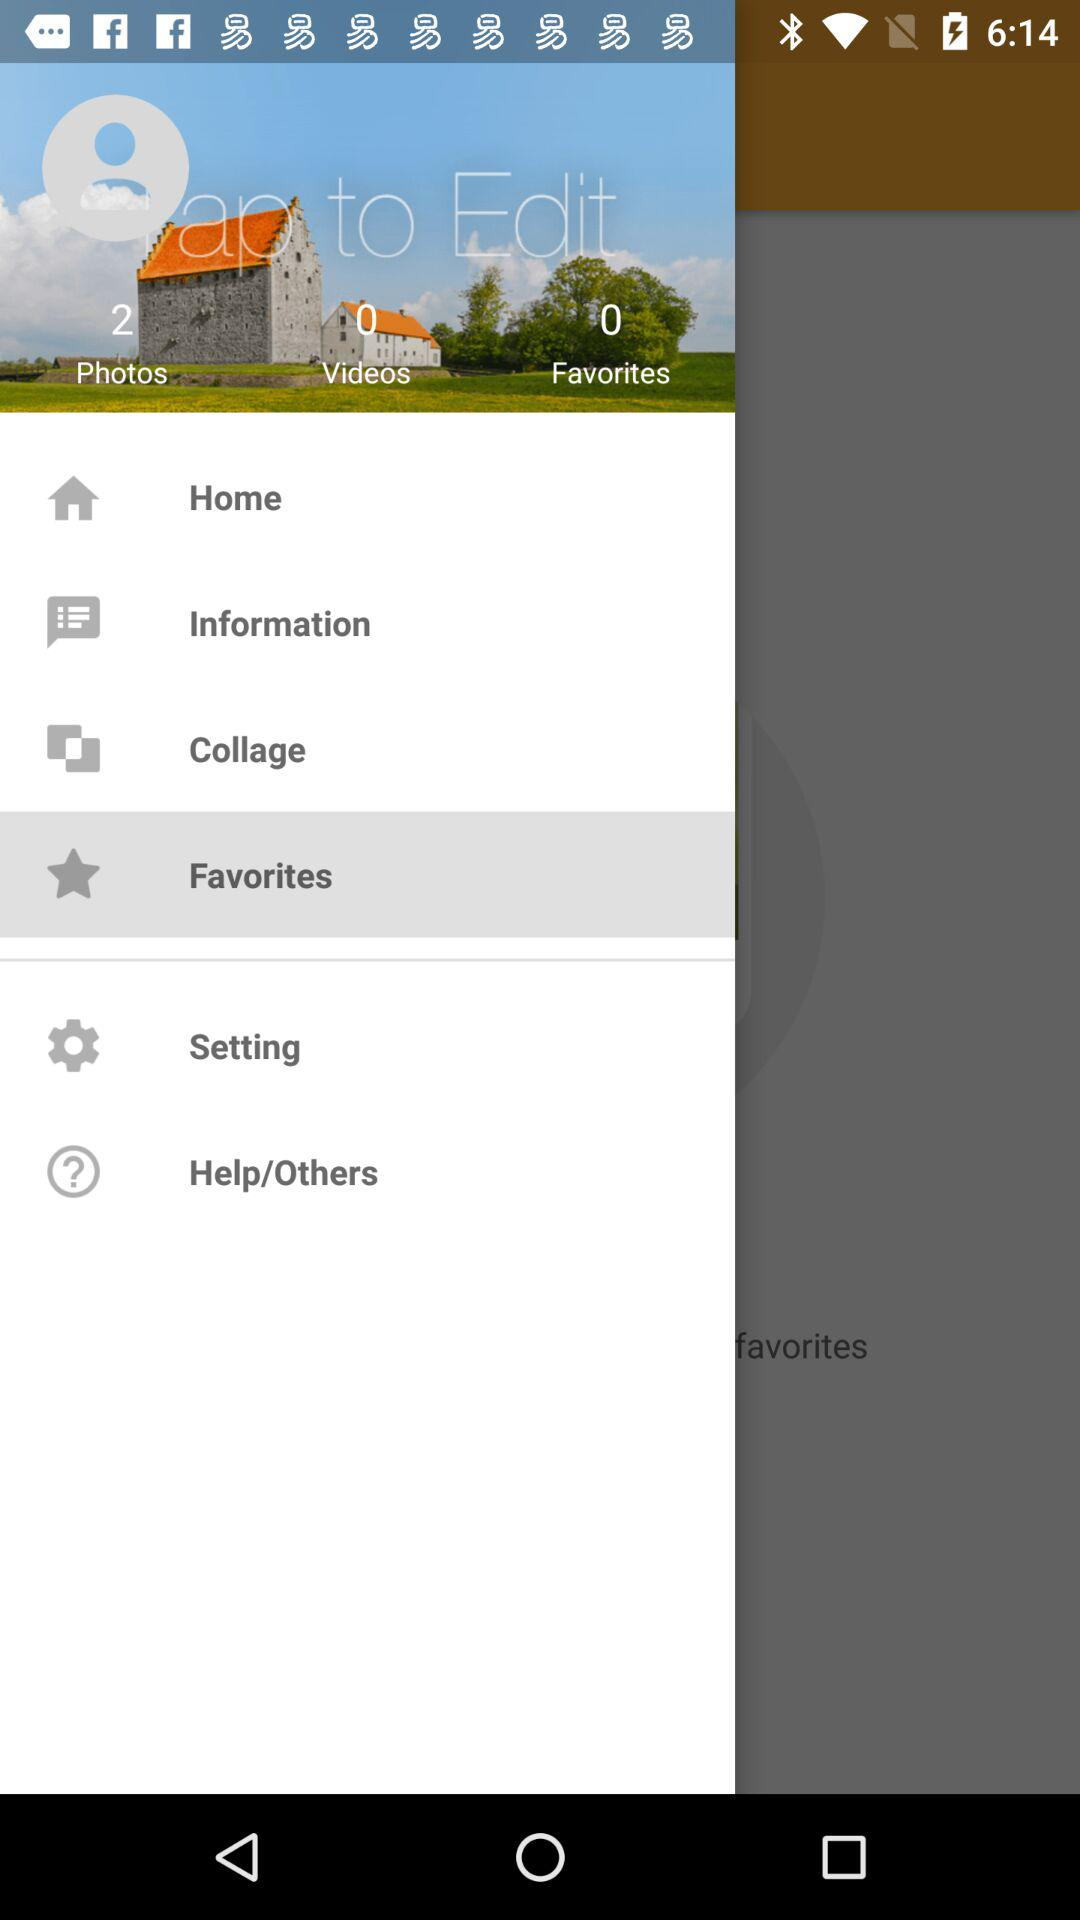Which is the selected item in the menu? The selected item in the menu is "Favorites". 